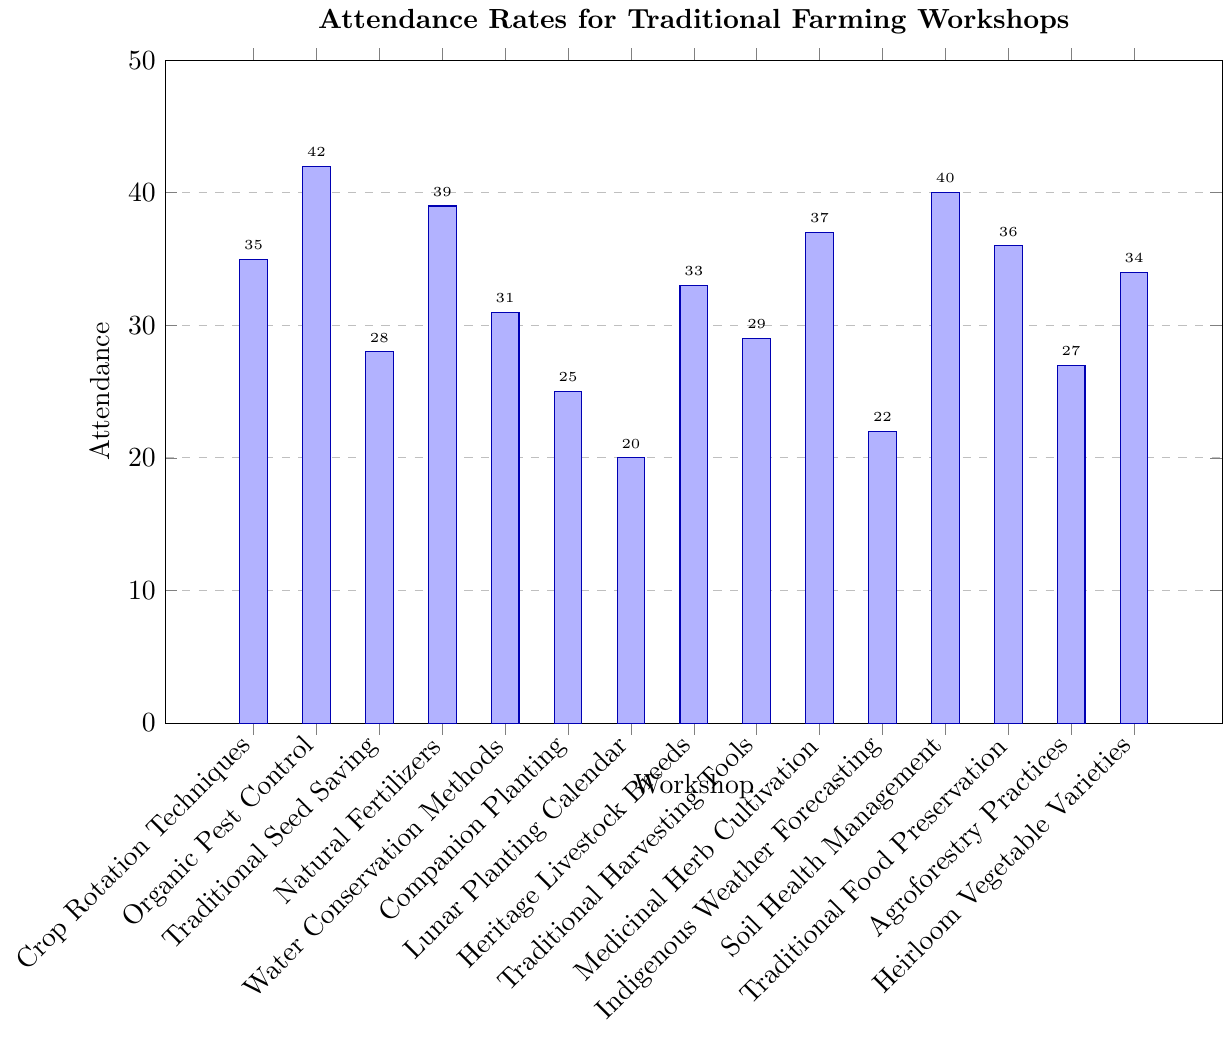Which workshop had the highest attendance? The highest attendance is represented by the tallest bar. In this case, "Organic Pest Control" has the highest bar with an attendance of 42.
Answer: Organic Pest Control Which workshop had the lowest attendance? The lowest attendance is represented by the shortest bar. The bar for "Lunar Planting Calendar" is the shortest with an attendance of 20.
Answer: Lunar Planting Calendar What is the total attendance for all workshops combined? Sum the attendance numbers for all workshops: (35 + 42 + 28 + 39 + 31 + 25 + 20 + 33 + 29 + 37 + 22 + 40 + 36 + 27 + 34). The total is 478.
Answer: 478 Which workshops had an attendance of 30 or more but less than 40? Identify bars with attendance between 30 and 39: "Crop Rotation Techniques" (35), "Natural Fertilizers" (39), "Water Conservation Methods" (31), "Heritage Livestock Breeds" (33), "Soil Health Management" (40, not included), "Traditional Food Preservation" (36), "Heirloom Vegetable Varieties" (34).
Answer: Crop Rotation Techniques, Natural Fertilizers, Water Conservation Methods, Heritage Livestock Breeds, Traditional Food Preservation, Heirloom Vegetable Varieties How many workshops had an attendance greater than the median value? First, find the median value by ordering the attendances: [20, 22, 25, 27, 28, 29, 31, 33, 34, 35, 36, 37, 39, 40, 42]. The median is 33. Then, count workshops with attendance greater than 33: "Organic Pest Control" (42), "Natural Fertilizers" (39), "Medicinal Herb Cultivation" (37), "Soil Health Management" (40), "Traditional Food Preservation" (36), "Heirloom Vegetable Varieties" (34). Thus, 6 workshops have attendance greater than 33.
Answer: 6 Which workshop had attendance closest to the average attendance? First, calculate the average attendance: 478 total attendance divided by 15 workshops equals approximately 31.87. Next, find the workshop with attendance closest to 31.87: "Heritage Livestock Breeds" (33) and "Water Conservation Methods" (31). The closer value is 31 (Water Conservation Methods).
Answer: Water Conservation Methods What is the difference in attendance between the most and least attended workshops? The highest attendance is 42 (Organic Pest Control), and the lowest is 20 (Lunar Planting Calendar). The difference is 42 - 20 = 22.
Answer: 22 How many workshops had attendance that was an even number? Identify workshops with even attendance numbers: (35 - odd, 42 - even, 28 - even, 39 - odd, 31 - odd, 25 - odd, 20 - even, 33 - odd, 29 - odd, 37 - odd, 22 - even, 40 - even, 36 - even, 27 - odd, 34 - even). Thus, there are 6 workshops with even attendance numbers.
Answer: 6 Which workshop had attendance just below 30? Identify the workshop with attendance immediately below 30: "Traditional Seed Saving" (28).
Answer: Traditional Seed Saving 